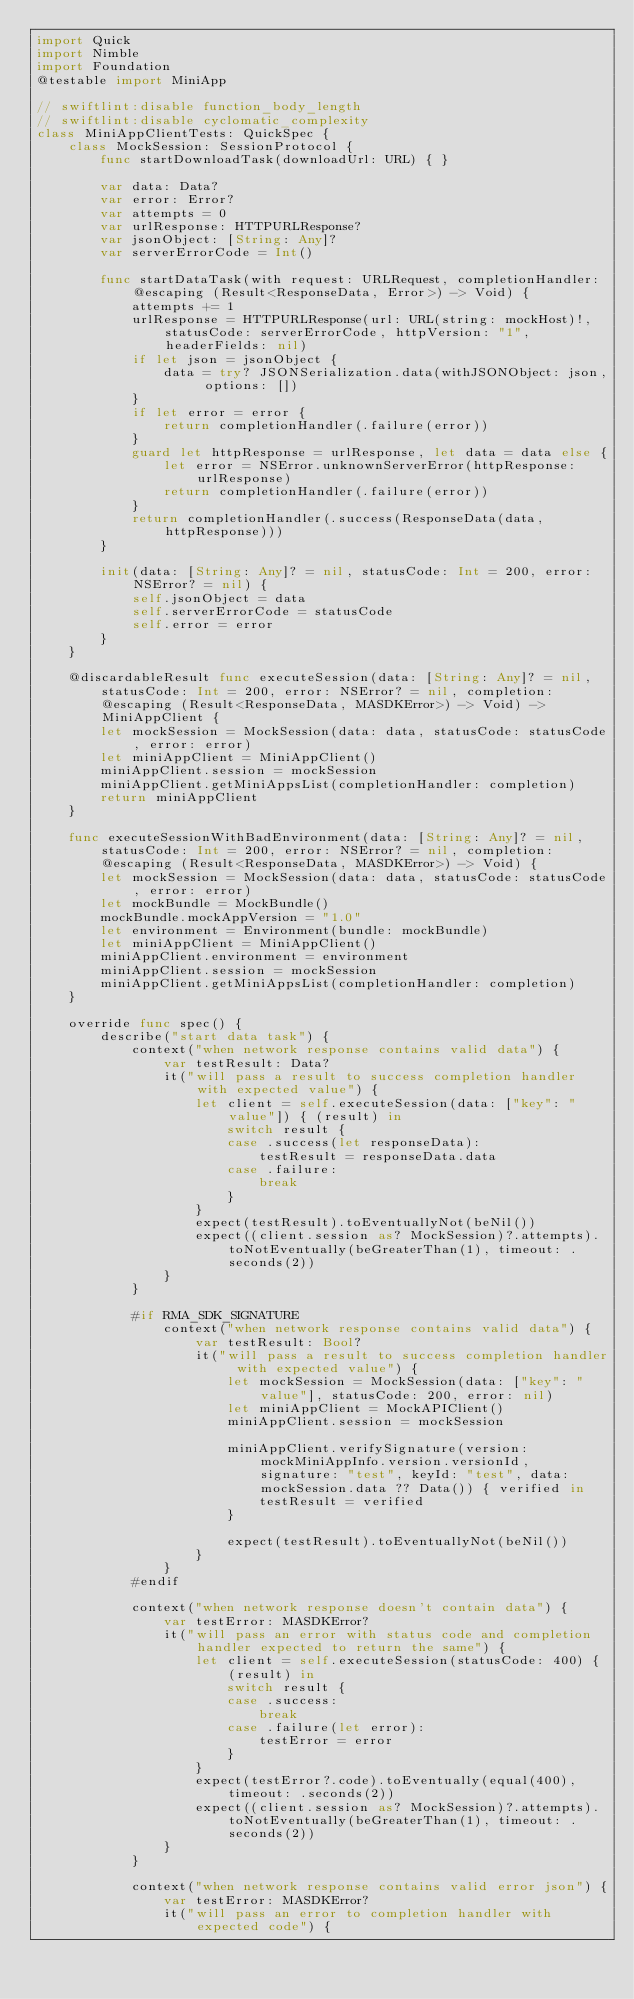<code> <loc_0><loc_0><loc_500><loc_500><_Swift_>import Quick
import Nimble
import Foundation
@testable import MiniApp

// swiftlint:disable function_body_length
// swiftlint:disable cyclomatic_complexity
class MiniAppClientTests: QuickSpec {
    class MockSession: SessionProtocol {
        func startDownloadTask(downloadUrl: URL) { }

        var data: Data?
        var error: Error?
        var attempts = 0
        var urlResponse: HTTPURLResponse?
        var jsonObject: [String: Any]?
        var serverErrorCode = Int()

        func startDataTask(with request: URLRequest, completionHandler: @escaping (Result<ResponseData, Error>) -> Void) {
            attempts += 1
            urlResponse = HTTPURLResponse(url: URL(string: mockHost)!, statusCode: serverErrorCode, httpVersion: "1", headerFields: nil)
            if let json = jsonObject {
                data = try? JSONSerialization.data(withJSONObject: json, options: [])
            }
            if let error = error {
                return completionHandler(.failure(error))
            }
            guard let httpResponse = urlResponse, let data = data else {
                let error = NSError.unknownServerError(httpResponse: urlResponse)
                return completionHandler(.failure(error))
            }
            return completionHandler(.success(ResponseData(data, httpResponse)))
        }

        init(data: [String: Any]? = nil, statusCode: Int = 200, error: NSError? = nil) {
            self.jsonObject = data
            self.serverErrorCode = statusCode
            self.error = error
        }
    }

    @discardableResult func executeSession(data: [String: Any]? = nil, statusCode: Int = 200, error: NSError? = nil, completion: @escaping (Result<ResponseData, MASDKError>) -> Void) -> MiniAppClient {
        let mockSession = MockSession(data: data, statusCode: statusCode, error: error)
        let miniAppClient = MiniAppClient()
        miniAppClient.session = mockSession
        miniAppClient.getMiniAppsList(completionHandler: completion)
        return miniAppClient
    }

    func executeSessionWithBadEnvironment(data: [String: Any]? = nil, statusCode: Int = 200, error: NSError? = nil, completion: @escaping (Result<ResponseData, MASDKError>) -> Void) {
        let mockSession = MockSession(data: data, statusCode: statusCode, error: error)
        let mockBundle = MockBundle()
        mockBundle.mockAppVersion = "1.0"
        let environment = Environment(bundle: mockBundle)
        let miniAppClient = MiniAppClient()
        miniAppClient.environment = environment
        miniAppClient.session = mockSession
        miniAppClient.getMiniAppsList(completionHandler: completion)
    }

    override func spec() {
        describe("start data task") {
            context("when network response contains valid data") {
                var testResult: Data?
                it("will pass a result to success completion handler with expected value") {
                    let client = self.executeSession(data: ["key": "value"]) { (result) in
                        switch result {
                        case .success(let responseData):
                            testResult = responseData.data
                        case .failure:
                            break
                        }
                    }
                    expect(testResult).toEventuallyNot(beNil())
                    expect((client.session as? MockSession)?.attempts).toNotEventually(beGreaterThan(1), timeout: .seconds(2))
                }
            }

            #if RMA_SDK_SIGNATURE
                context("when network response contains valid data") {
                    var testResult: Bool?
                    it("will pass a result to success completion handler with expected value") {
                        let mockSession = MockSession(data: ["key": "value"], statusCode: 200, error: nil)
                        let miniAppClient = MockAPIClient()
                        miniAppClient.session = mockSession

                        miniAppClient.verifySignature(version: mockMiniAppInfo.version.versionId, signature: "test", keyId: "test", data: mockSession.data ?? Data()) { verified in
                            testResult = verified
                        }

                        expect(testResult).toEventuallyNot(beNil())
                    }
                }
            #endif

            context("when network response doesn't contain data") {
                var testError: MASDKError?
                it("will pass an error with status code and completion handler expected to return the same") {
                    let client = self.executeSession(statusCode: 400) { (result) in
                        switch result {
                        case .success:
                            break
                        case .failure(let error):
                            testError = error
                        }
                    }
                    expect(testError?.code).toEventually(equal(400), timeout: .seconds(2))
                    expect((client.session as? MockSession)?.attempts).toNotEventually(beGreaterThan(1), timeout: .seconds(2))
                }
            }

            context("when network response contains valid error json") {
                var testError: MASDKError?
                it("will pass an error to completion handler with expected code") {</code> 